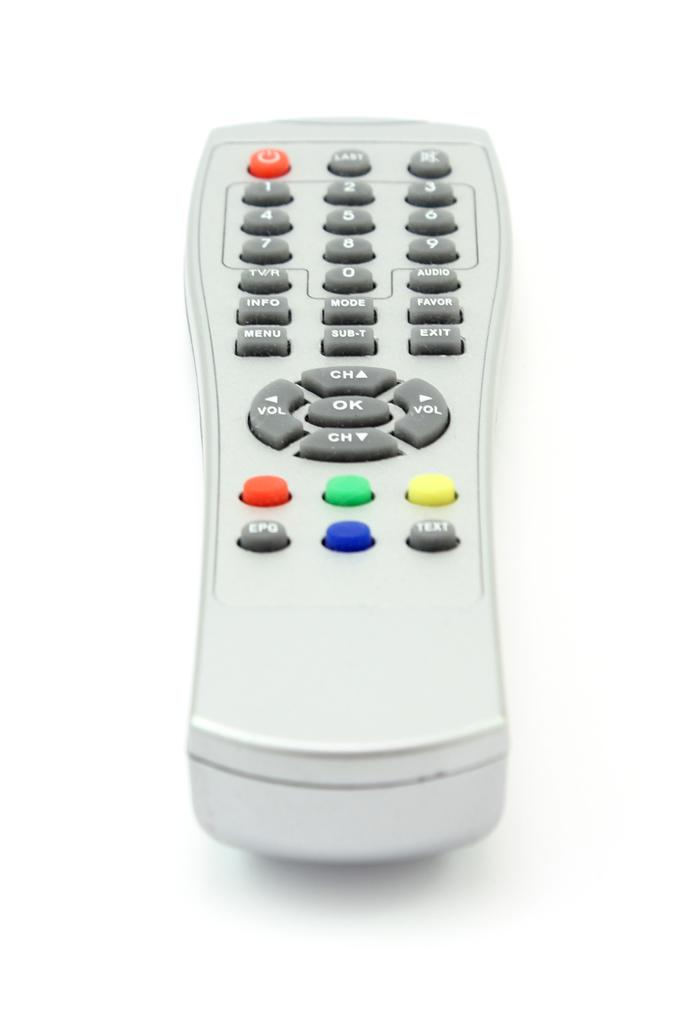Provide a one-sentence caption for the provided image. A white remote control with an OK button in the middle. 